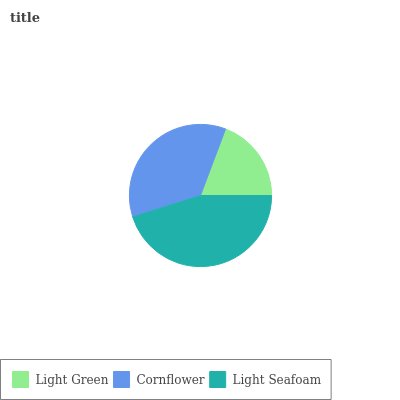Is Light Green the minimum?
Answer yes or no. Yes. Is Light Seafoam the maximum?
Answer yes or no. Yes. Is Cornflower the minimum?
Answer yes or no. No. Is Cornflower the maximum?
Answer yes or no. No. Is Cornflower greater than Light Green?
Answer yes or no. Yes. Is Light Green less than Cornflower?
Answer yes or no. Yes. Is Light Green greater than Cornflower?
Answer yes or no. No. Is Cornflower less than Light Green?
Answer yes or no. No. Is Cornflower the high median?
Answer yes or no. Yes. Is Cornflower the low median?
Answer yes or no. Yes. Is Light Green the high median?
Answer yes or no. No. Is Light Seafoam the low median?
Answer yes or no. No. 